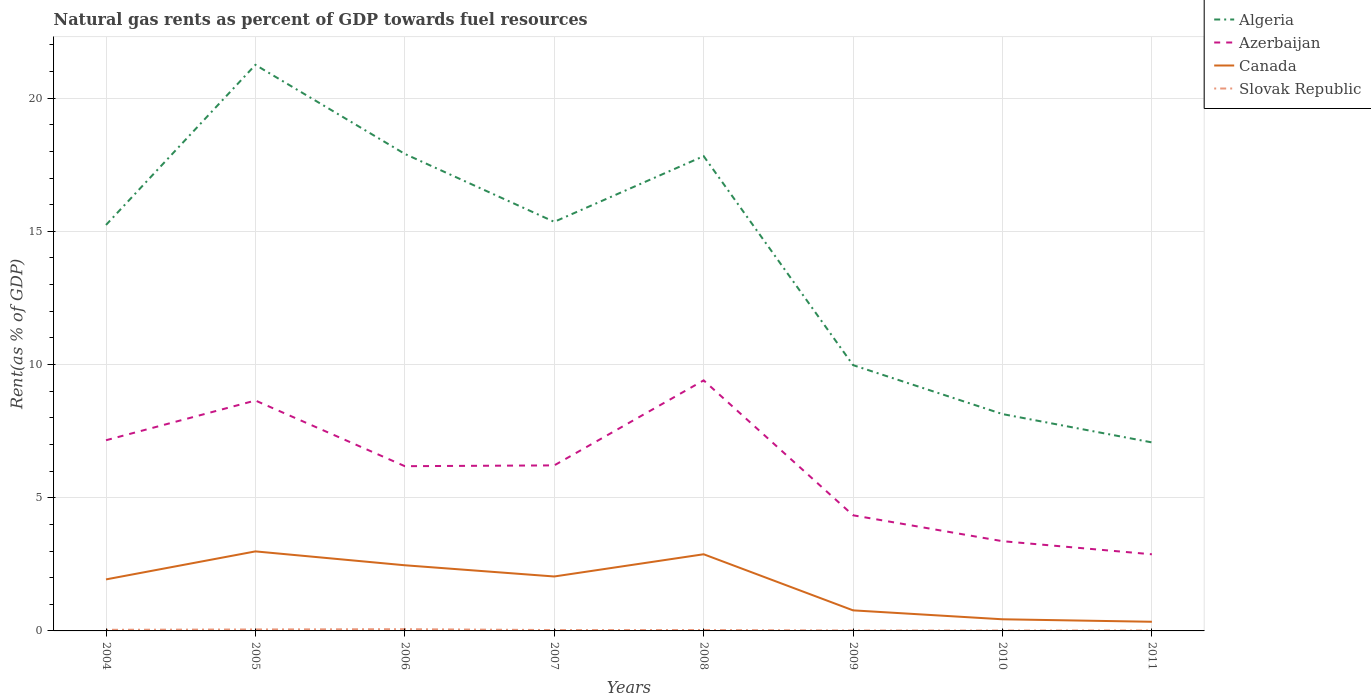Across all years, what is the maximum matural gas rent in Algeria?
Your answer should be very brief. 7.08. In which year was the matural gas rent in Slovak Republic maximum?
Make the answer very short. 2010. What is the total matural gas rent in Slovak Republic in the graph?
Ensure brevity in your answer.  0.03. What is the difference between the highest and the second highest matural gas rent in Algeria?
Keep it short and to the point. 14.17. What is the difference between the highest and the lowest matural gas rent in Algeria?
Offer a very short reply. 5. Is the matural gas rent in Azerbaijan strictly greater than the matural gas rent in Algeria over the years?
Offer a very short reply. Yes. How many lines are there?
Ensure brevity in your answer.  4. How many years are there in the graph?
Ensure brevity in your answer.  8. What is the difference between two consecutive major ticks on the Y-axis?
Your answer should be compact. 5. Does the graph contain grids?
Provide a short and direct response. Yes. How many legend labels are there?
Your answer should be very brief. 4. What is the title of the graph?
Give a very brief answer. Natural gas rents as percent of GDP towards fuel resources. What is the label or title of the Y-axis?
Offer a terse response. Rent(as % of GDP). What is the Rent(as % of GDP) in Algeria in 2004?
Make the answer very short. 15.24. What is the Rent(as % of GDP) in Azerbaijan in 2004?
Provide a short and direct response. 7.16. What is the Rent(as % of GDP) in Canada in 2004?
Your answer should be very brief. 1.93. What is the Rent(as % of GDP) in Slovak Republic in 2004?
Give a very brief answer. 0.04. What is the Rent(as % of GDP) in Algeria in 2005?
Give a very brief answer. 21.25. What is the Rent(as % of GDP) of Azerbaijan in 2005?
Your answer should be compact. 8.65. What is the Rent(as % of GDP) of Canada in 2005?
Your answer should be very brief. 2.99. What is the Rent(as % of GDP) of Slovak Republic in 2005?
Make the answer very short. 0.05. What is the Rent(as % of GDP) of Algeria in 2006?
Offer a very short reply. 17.91. What is the Rent(as % of GDP) in Azerbaijan in 2006?
Your answer should be compact. 6.18. What is the Rent(as % of GDP) in Canada in 2006?
Your response must be concise. 2.46. What is the Rent(as % of GDP) in Slovak Republic in 2006?
Your answer should be compact. 0.07. What is the Rent(as % of GDP) in Algeria in 2007?
Ensure brevity in your answer.  15.36. What is the Rent(as % of GDP) in Azerbaijan in 2007?
Offer a very short reply. 6.21. What is the Rent(as % of GDP) of Canada in 2007?
Give a very brief answer. 2.04. What is the Rent(as % of GDP) in Slovak Republic in 2007?
Your answer should be compact. 0.03. What is the Rent(as % of GDP) of Algeria in 2008?
Provide a short and direct response. 17.82. What is the Rent(as % of GDP) in Azerbaijan in 2008?
Your response must be concise. 9.41. What is the Rent(as % of GDP) of Canada in 2008?
Offer a very short reply. 2.88. What is the Rent(as % of GDP) of Slovak Republic in 2008?
Give a very brief answer. 0.03. What is the Rent(as % of GDP) in Algeria in 2009?
Offer a very short reply. 9.98. What is the Rent(as % of GDP) in Azerbaijan in 2009?
Make the answer very short. 4.34. What is the Rent(as % of GDP) in Canada in 2009?
Offer a very short reply. 0.77. What is the Rent(as % of GDP) in Slovak Republic in 2009?
Make the answer very short. 0.02. What is the Rent(as % of GDP) in Algeria in 2010?
Provide a succinct answer. 8.14. What is the Rent(as % of GDP) in Azerbaijan in 2010?
Your answer should be compact. 3.37. What is the Rent(as % of GDP) in Canada in 2010?
Provide a short and direct response. 0.44. What is the Rent(as % of GDP) of Slovak Republic in 2010?
Offer a terse response. 0.01. What is the Rent(as % of GDP) of Algeria in 2011?
Ensure brevity in your answer.  7.08. What is the Rent(as % of GDP) of Azerbaijan in 2011?
Provide a succinct answer. 2.88. What is the Rent(as % of GDP) of Canada in 2011?
Offer a very short reply. 0.34. What is the Rent(as % of GDP) in Slovak Republic in 2011?
Give a very brief answer. 0.02. Across all years, what is the maximum Rent(as % of GDP) of Algeria?
Offer a very short reply. 21.25. Across all years, what is the maximum Rent(as % of GDP) of Azerbaijan?
Offer a very short reply. 9.41. Across all years, what is the maximum Rent(as % of GDP) of Canada?
Your answer should be very brief. 2.99. Across all years, what is the maximum Rent(as % of GDP) in Slovak Republic?
Make the answer very short. 0.07. Across all years, what is the minimum Rent(as % of GDP) of Algeria?
Keep it short and to the point. 7.08. Across all years, what is the minimum Rent(as % of GDP) of Azerbaijan?
Provide a succinct answer. 2.88. Across all years, what is the minimum Rent(as % of GDP) of Canada?
Your response must be concise. 0.34. Across all years, what is the minimum Rent(as % of GDP) in Slovak Republic?
Offer a terse response. 0.01. What is the total Rent(as % of GDP) in Algeria in the graph?
Your response must be concise. 112.78. What is the total Rent(as % of GDP) in Azerbaijan in the graph?
Make the answer very short. 48.2. What is the total Rent(as % of GDP) of Canada in the graph?
Give a very brief answer. 13.86. What is the total Rent(as % of GDP) of Slovak Republic in the graph?
Make the answer very short. 0.28. What is the difference between the Rent(as % of GDP) of Algeria in 2004 and that in 2005?
Provide a succinct answer. -6.01. What is the difference between the Rent(as % of GDP) in Azerbaijan in 2004 and that in 2005?
Provide a short and direct response. -1.49. What is the difference between the Rent(as % of GDP) of Canada in 2004 and that in 2005?
Your response must be concise. -1.05. What is the difference between the Rent(as % of GDP) in Slovak Republic in 2004 and that in 2005?
Your response must be concise. -0.01. What is the difference between the Rent(as % of GDP) in Algeria in 2004 and that in 2006?
Give a very brief answer. -2.67. What is the difference between the Rent(as % of GDP) of Azerbaijan in 2004 and that in 2006?
Offer a very short reply. 0.97. What is the difference between the Rent(as % of GDP) in Canada in 2004 and that in 2006?
Make the answer very short. -0.53. What is the difference between the Rent(as % of GDP) of Slovak Republic in 2004 and that in 2006?
Ensure brevity in your answer.  -0.02. What is the difference between the Rent(as % of GDP) in Algeria in 2004 and that in 2007?
Give a very brief answer. -0.12. What is the difference between the Rent(as % of GDP) in Azerbaijan in 2004 and that in 2007?
Make the answer very short. 0.94. What is the difference between the Rent(as % of GDP) of Canada in 2004 and that in 2007?
Make the answer very short. -0.11. What is the difference between the Rent(as % of GDP) of Slovak Republic in 2004 and that in 2007?
Provide a succinct answer. 0.01. What is the difference between the Rent(as % of GDP) in Algeria in 2004 and that in 2008?
Make the answer very short. -2.58. What is the difference between the Rent(as % of GDP) of Azerbaijan in 2004 and that in 2008?
Offer a terse response. -2.25. What is the difference between the Rent(as % of GDP) in Canada in 2004 and that in 2008?
Offer a very short reply. -0.94. What is the difference between the Rent(as % of GDP) in Slovak Republic in 2004 and that in 2008?
Your response must be concise. 0.01. What is the difference between the Rent(as % of GDP) in Algeria in 2004 and that in 2009?
Offer a terse response. 5.26. What is the difference between the Rent(as % of GDP) of Azerbaijan in 2004 and that in 2009?
Your response must be concise. 2.82. What is the difference between the Rent(as % of GDP) in Canada in 2004 and that in 2009?
Your answer should be very brief. 1.16. What is the difference between the Rent(as % of GDP) of Slovak Republic in 2004 and that in 2009?
Your response must be concise. 0.03. What is the difference between the Rent(as % of GDP) of Algeria in 2004 and that in 2010?
Your answer should be compact. 7.1. What is the difference between the Rent(as % of GDP) in Azerbaijan in 2004 and that in 2010?
Make the answer very short. 3.79. What is the difference between the Rent(as % of GDP) in Canada in 2004 and that in 2010?
Your response must be concise. 1.5. What is the difference between the Rent(as % of GDP) of Slovak Republic in 2004 and that in 2010?
Your response must be concise. 0.03. What is the difference between the Rent(as % of GDP) in Algeria in 2004 and that in 2011?
Make the answer very short. 8.16. What is the difference between the Rent(as % of GDP) of Azerbaijan in 2004 and that in 2011?
Provide a succinct answer. 4.28. What is the difference between the Rent(as % of GDP) in Canada in 2004 and that in 2011?
Give a very brief answer. 1.59. What is the difference between the Rent(as % of GDP) of Slovak Republic in 2004 and that in 2011?
Keep it short and to the point. 0.03. What is the difference between the Rent(as % of GDP) in Algeria in 2005 and that in 2006?
Provide a succinct answer. 3.34. What is the difference between the Rent(as % of GDP) of Azerbaijan in 2005 and that in 2006?
Provide a succinct answer. 2.47. What is the difference between the Rent(as % of GDP) in Canada in 2005 and that in 2006?
Provide a short and direct response. 0.52. What is the difference between the Rent(as % of GDP) in Slovak Republic in 2005 and that in 2006?
Your response must be concise. -0.01. What is the difference between the Rent(as % of GDP) in Algeria in 2005 and that in 2007?
Offer a terse response. 5.89. What is the difference between the Rent(as % of GDP) in Azerbaijan in 2005 and that in 2007?
Provide a short and direct response. 2.44. What is the difference between the Rent(as % of GDP) of Canada in 2005 and that in 2007?
Keep it short and to the point. 0.94. What is the difference between the Rent(as % of GDP) in Slovak Republic in 2005 and that in 2007?
Your answer should be compact. 0.02. What is the difference between the Rent(as % of GDP) of Algeria in 2005 and that in 2008?
Your response must be concise. 3.43. What is the difference between the Rent(as % of GDP) of Azerbaijan in 2005 and that in 2008?
Make the answer very short. -0.76. What is the difference between the Rent(as % of GDP) of Canada in 2005 and that in 2008?
Offer a very short reply. 0.11. What is the difference between the Rent(as % of GDP) in Slovak Republic in 2005 and that in 2008?
Your response must be concise. 0.02. What is the difference between the Rent(as % of GDP) in Algeria in 2005 and that in 2009?
Offer a very short reply. 11.27. What is the difference between the Rent(as % of GDP) of Azerbaijan in 2005 and that in 2009?
Your answer should be very brief. 4.31. What is the difference between the Rent(as % of GDP) of Canada in 2005 and that in 2009?
Provide a succinct answer. 2.21. What is the difference between the Rent(as % of GDP) in Slovak Republic in 2005 and that in 2009?
Make the answer very short. 0.04. What is the difference between the Rent(as % of GDP) in Algeria in 2005 and that in 2010?
Give a very brief answer. 13.11. What is the difference between the Rent(as % of GDP) in Azerbaijan in 2005 and that in 2010?
Your answer should be very brief. 5.28. What is the difference between the Rent(as % of GDP) of Canada in 2005 and that in 2010?
Ensure brevity in your answer.  2.55. What is the difference between the Rent(as % of GDP) in Slovak Republic in 2005 and that in 2010?
Ensure brevity in your answer.  0.04. What is the difference between the Rent(as % of GDP) in Algeria in 2005 and that in 2011?
Make the answer very short. 14.17. What is the difference between the Rent(as % of GDP) in Azerbaijan in 2005 and that in 2011?
Offer a very short reply. 5.77. What is the difference between the Rent(as % of GDP) in Canada in 2005 and that in 2011?
Provide a succinct answer. 2.64. What is the difference between the Rent(as % of GDP) of Slovak Republic in 2005 and that in 2011?
Keep it short and to the point. 0.04. What is the difference between the Rent(as % of GDP) in Algeria in 2006 and that in 2007?
Your response must be concise. 2.55. What is the difference between the Rent(as % of GDP) of Azerbaijan in 2006 and that in 2007?
Make the answer very short. -0.03. What is the difference between the Rent(as % of GDP) in Canada in 2006 and that in 2007?
Provide a short and direct response. 0.42. What is the difference between the Rent(as % of GDP) of Slovak Republic in 2006 and that in 2007?
Provide a succinct answer. 0.03. What is the difference between the Rent(as % of GDP) of Algeria in 2006 and that in 2008?
Offer a very short reply. 0.08. What is the difference between the Rent(as % of GDP) in Azerbaijan in 2006 and that in 2008?
Your response must be concise. -3.22. What is the difference between the Rent(as % of GDP) in Canada in 2006 and that in 2008?
Ensure brevity in your answer.  -0.41. What is the difference between the Rent(as % of GDP) of Slovak Republic in 2006 and that in 2008?
Offer a very short reply. 0.03. What is the difference between the Rent(as % of GDP) in Algeria in 2006 and that in 2009?
Give a very brief answer. 7.93. What is the difference between the Rent(as % of GDP) in Azerbaijan in 2006 and that in 2009?
Ensure brevity in your answer.  1.84. What is the difference between the Rent(as % of GDP) in Canada in 2006 and that in 2009?
Make the answer very short. 1.69. What is the difference between the Rent(as % of GDP) of Slovak Republic in 2006 and that in 2009?
Your response must be concise. 0.05. What is the difference between the Rent(as % of GDP) of Algeria in 2006 and that in 2010?
Provide a short and direct response. 9.77. What is the difference between the Rent(as % of GDP) in Azerbaijan in 2006 and that in 2010?
Keep it short and to the point. 2.82. What is the difference between the Rent(as % of GDP) of Canada in 2006 and that in 2010?
Offer a terse response. 2.03. What is the difference between the Rent(as % of GDP) in Slovak Republic in 2006 and that in 2010?
Your answer should be very brief. 0.05. What is the difference between the Rent(as % of GDP) of Algeria in 2006 and that in 2011?
Your answer should be very brief. 10.83. What is the difference between the Rent(as % of GDP) in Azerbaijan in 2006 and that in 2011?
Provide a short and direct response. 3.31. What is the difference between the Rent(as % of GDP) in Canada in 2006 and that in 2011?
Your response must be concise. 2.12. What is the difference between the Rent(as % of GDP) of Slovak Republic in 2006 and that in 2011?
Make the answer very short. 0.05. What is the difference between the Rent(as % of GDP) of Algeria in 2007 and that in 2008?
Your answer should be very brief. -2.47. What is the difference between the Rent(as % of GDP) in Azerbaijan in 2007 and that in 2008?
Offer a very short reply. -3.19. What is the difference between the Rent(as % of GDP) of Canada in 2007 and that in 2008?
Offer a very short reply. -0.83. What is the difference between the Rent(as % of GDP) of Slovak Republic in 2007 and that in 2008?
Your answer should be very brief. -0. What is the difference between the Rent(as % of GDP) of Algeria in 2007 and that in 2009?
Keep it short and to the point. 5.38. What is the difference between the Rent(as % of GDP) of Azerbaijan in 2007 and that in 2009?
Your answer should be compact. 1.87. What is the difference between the Rent(as % of GDP) of Canada in 2007 and that in 2009?
Give a very brief answer. 1.27. What is the difference between the Rent(as % of GDP) in Slovak Republic in 2007 and that in 2009?
Provide a short and direct response. 0.02. What is the difference between the Rent(as % of GDP) in Algeria in 2007 and that in 2010?
Ensure brevity in your answer.  7.22. What is the difference between the Rent(as % of GDP) in Azerbaijan in 2007 and that in 2010?
Your answer should be compact. 2.85. What is the difference between the Rent(as % of GDP) of Canada in 2007 and that in 2010?
Your answer should be compact. 1.61. What is the difference between the Rent(as % of GDP) of Slovak Republic in 2007 and that in 2010?
Offer a terse response. 0.02. What is the difference between the Rent(as % of GDP) of Algeria in 2007 and that in 2011?
Provide a succinct answer. 8.28. What is the difference between the Rent(as % of GDP) of Azerbaijan in 2007 and that in 2011?
Your answer should be very brief. 3.34. What is the difference between the Rent(as % of GDP) in Canada in 2007 and that in 2011?
Offer a very short reply. 1.7. What is the difference between the Rent(as % of GDP) in Slovak Republic in 2007 and that in 2011?
Your response must be concise. 0.02. What is the difference between the Rent(as % of GDP) of Algeria in 2008 and that in 2009?
Your response must be concise. 7.85. What is the difference between the Rent(as % of GDP) in Azerbaijan in 2008 and that in 2009?
Provide a short and direct response. 5.07. What is the difference between the Rent(as % of GDP) of Canada in 2008 and that in 2009?
Offer a very short reply. 2.11. What is the difference between the Rent(as % of GDP) of Slovak Republic in 2008 and that in 2009?
Keep it short and to the point. 0.02. What is the difference between the Rent(as % of GDP) in Algeria in 2008 and that in 2010?
Your answer should be compact. 9.68. What is the difference between the Rent(as % of GDP) of Azerbaijan in 2008 and that in 2010?
Provide a short and direct response. 6.04. What is the difference between the Rent(as % of GDP) in Canada in 2008 and that in 2010?
Make the answer very short. 2.44. What is the difference between the Rent(as % of GDP) in Slovak Republic in 2008 and that in 2010?
Offer a terse response. 0.02. What is the difference between the Rent(as % of GDP) in Algeria in 2008 and that in 2011?
Ensure brevity in your answer.  10.75. What is the difference between the Rent(as % of GDP) of Azerbaijan in 2008 and that in 2011?
Provide a short and direct response. 6.53. What is the difference between the Rent(as % of GDP) in Canada in 2008 and that in 2011?
Offer a very short reply. 2.53. What is the difference between the Rent(as % of GDP) in Slovak Republic in 2008 and that in 2011?
Provide a succinct answer. 0.02. What is the difference between the Rent(as % of GDP) in Algeria in 2009 and that in 2010?
Ensure brevity in your answer.  1.84. What is the difference between the Rent(as % of GDP) in Azerbaijan in 2009 and that in 2010?
Make the answer very short. 0.97. What is the difference between the Rent(as % of GDP) of Canada in 2009 and that in 2010?
Provide a short and direct response. 0.34. What is the difference between the Rent(as % of GDP) in Slovak Republic in 2009 and that in 2010?
Your answer should be very brief. 0. What is the difference between the Rent(as % of GDP) in Algeria in 2009 and that in 2011?
Ensure brevity in your answer.  2.9. What is the difference between the Rent(as % of GDP) in Azerbaijan in 2009 and that in 2011?
Your answer should be very brief. 1.46. What is the difference between the Rent(as % of GDP) in Canada in 2009 and that in 2011?
Keep it short and to the point. 0.43. What is the difference between the Rent(as % of GDP) of Slovak Republic in 2009 and that in 2011?
Your response must be concise. -0. What is the difference between the Rent(as % of GDP) of Algeria in 2010 and that in 2011?
Give a very brief answer. 1.06. What is the difference between the Rent(as % of GDP) of Azerbaijan in 2010 and that in 2011?
Provide a succinct answer. 0.49. What is the difference between the Rent(as % of GDP) of Canada in 2010 and that in 2011?
Make the answer very short. 0.09. What is the difference between the Rent(as % of GDP) of Slovak Republic in 2010 and that in 2011?
Ensure brevity in your answer.  -0. What is the difference between the Rent(as % of GDP) of Algeria in 2004 and the Rent(as % of GDP) of Azerbaijan in 2005?
Offer a terse response. 6.59. What is the difference between the Rent(as % of GDP) in Algeria in 2004 and the Rent(as % of GDP) in Canada in 2005?
Your answer should be compact. 12.25. What is the difference between the Rent(as % of GDP) in Algeria in 2004 and the Rent(as % of GDP) in Slovak Republic in 2005?
Keep it short and to the point. 15.19. What is the difference between the Rent(as % of GDP) of Azerbaijan in 2004 and the Rent(as % of GDP) of Canada in 2005?
Your answer should be compact. 4.17. What is the difference between the Rent(as % of GDP) of Azerbaijan in 2004 and the Rent(as % of GDP) of Slovak Republic in 2005?
Provide a succinct answer. 7.1. What is the difference between the Rent(as % of GDP) in Canada in 2004 and the Rent(as % of GDP) in Slovak Republic in 2005?
Provide a short and direct response. 1.88. What is the difference between the Rent(as % of GDP) of Algeria in 2004 and the Rent(as % of GDP) of Azerbaijan in 2006?
Provide a succinct answer. 9.06. What is the difference between the Rent(as % of GDP) of Algeria in 2004 and the Rent(as % of GDP) of Canada in 2006?
Your answer should be very brief. 12.78. What is the difference between the Rent(as % of GDP) in Algeria in 2004 and the Rent(as % of GDP) in Slovak Republic in 2006?
Provide a short and direct response. 15.18. What is the difference between the Rent(as % of GDP) in Azerbaijan in 2004 and the Rent(as % of GDP) in Canada in 2006?
Give a very brief answer. 4.69. What is the difference between the Rent(as % of GDP) of Azerbaijan in 2004 and the Rent(as % of GDP) of Slovak Republic in 2006?
Your response must be concise. 7.09. What is the difference between the Rent(as % of GDP) of Canada in 2004 and the Rent(as % of GDP) of Slovak Republic in 2006?
Ensure brevity in your answer.  1.87. What is the difference between the Rent(as % of GDP) of Algeria in 2004 and the Rent(as % of GDP) of Azerbaijan in 2007?
Your answer should be compact. 9.03. What is the difference between the Rent(as % of GDP) of Algeria in 2004 and the Rent(as % of GDP) of Canada in 2007?
Offer a very short reply. 13.2. What is the difference between the Rent(as % of GDP) of Algeria in 2004 and the Rent(as % of GDP) of Slovak Republic in 2007?
Ensure brevity in your answer.  15.21. What is the difference between the Rent(as % of GDP) in Azerbaijan in 2004 and the Rent(as % of GDP) in Canada in 2007?
Make the answer very short. 5.12. What is the difference between the Rent(as % of GDP) in Azerbaijan in 2004 and the Rent(as % of GDP) in Slovak Republic in 2007?
Give a very brief answer. 7.13. What is the difference between the Rent(as % of GDP) of Canada in 2004 and the Rent(as % of GDP) of Slovak Republic in 2007?
Offer a terse response. 1.9. What is the difference between the Rent(as % of GDP) of Algeria in 2004 and the Rent(as % of GDP) of Azerbaijan in 2008?
Make the answer very short. 5.83. What is the difference between the Rent(as % of GDP) in Algeria in 2004 and the Rent(as % of GDP) in Canada in 2008?
Keep it short and to the point. 12.36. What is the difference between the Rent(as % of GDP) of Algeria in 2004 and the Rent(as % of GDP) of Slovak Republic in 2008?
Keep it short and to the point. 15.21. What is the difference between the Rent(as % of GDP) of Azerbaijan in 2004 and the Rent(as % of GDP) of Canada in 2008?
Offer a terse response. 4.28. What is the difference between the Rent(as % of GDP) of Azerbaijan in 2004 and the Rent(as % of GDP) of Slovak Republic in 2008?
Offer a very short reply. 7.12. What is the difference between the Rent(as % of GDP) in Canada in 2004 and the Rent(as % of GDP) in Slovak Republic in 2008?
Ensure brevity in your answer.  1.9. What is the difference between the Rent(as % of GDP) of Algeria in 2004 and the Rent(as % of GDP) of Azerbaijan in 2009?
Your response must be concise. 10.9. What is the difference between the Rent(as % of GDP) in Algeria in 2004 and the Rent(as % of GDP) in Canada in 2009?
Your answer should be very brief. 14.47. What is the difference between the Rent(as % of GDP) of Algeria in 2004 and the Rent(as % of GDP) of Slovak Republic in 2009?
Your response must be concise. 15.22. What is the difference between the Rent(as % of GDP) of Azerbaijan in 2004 and the Rent(as % of GDP) of Canada in 2009?
Give a very brief answer. 6.39. What is the difference between the Rent(as % of GDP) of Azerbaijan in 2004 and the Rent(as % of GDP) of Slovak Republic in 2009?
Ensure brevity in your answer.  7.14. What is the difference between the Rent(as % of GDP) in Canada in 2004 and the Rent(as % of GDP) in Slovak Republic in 2009?
Your answer should be very brief. 1.92. What is the difference between the Rent(as % of GDP) of Algeria in 2004 and the Rent(as % of GDP) of Azerbaijan in 2010?
Your answer should be compact. 11.87. What is the difference between the Rent(as % of GDP) of Algeria in 2004 and the Rent(as % of GDP) of Canada in 2010?
Offer a terse response. 14.8. What is the difference between the Rent(as % of GDP) of Algeria in 2004 and the Rent(as % of GDP) of Slovak Republic in 2010?
Make the answer very short. 15.23. What is the difference between the Rent(as % of GDP) of Azerbaijan in 2004 and the Rent(as % of GDP) of Canada in 2010?
Offer a very short reply. 6.72. What is the difference between the Rent(as % of GDP) of Azerbaijan in 2004 and the Rent(as % of GDP) of Slovak Republic in 2010?
Your answer should be compact. 7.14. What is the difference between the Rent(as % of GDP) of Canada in 2004 and the Rent(as % of GDP) of Slovak Republic in 2010?
Your response must be concise. 1.92. What is the difference between the Rent(as % of GDP) in Algeria in 2004 and the Rent(as % of GDP) in Azerbaijan in 2011?
Your answer should be very brief. 12.36. What is the difference between the Rent(as % of GDP) in Algeria in 2004 and the Rent(as % of GDP) in Canada in 2011?
Ensure brevity in your answer.  14.9. What is the difference between the Rent(as % of GDP) of Algeria in 2004 and the Rent(as % of GDP) of Slovak Republic in 2011?
Ensure brevity in your answer.  15.22. What is the difference between the Rent(as % of GDP) of Azerbaijan in 2004 and the Rent(as % of GDP) of Canada in 2011?
Your answer should be very brief. 6.81. What is the difference between the Rent(as % of GDP) of Azerbaijan in 2004 and the Rent(as % of GDP) of Slovak Republic in 2011?
Provide a succinct answer. 7.14. What is the difference between the Rent(as % of GDP) of Canada in 2004 and the Rent(as % of GDP) of Slovak Republic in 2011?
Offer a terse response. 1.92. What is the difference between the Rent(as % of GDP) in Algeria in 2005 and the Rent(as % of GDP) in Azerbaijan in 2006?
Ensure brevity in your answer.  15.07. What is the difference between the Rent(as % of GDP) of Algeria in 2005 and the Rent(as % of GDP) of Canada in 2006?
Offer a very short reply. 18.79. What is the difference between the Rent(as % of GDP) of Algeria in 2005 and the Rent(as % of GDP) of Slovak Republic in 2006?
Your answer should be very brief. 21.19. What is the difference between the Rent(as % of GDP) of Azerbaijan in 2005 and the Rent(as % of GDP) of Canada in 2006?
Offer a terse response. 6.18. What is the difference between the Rent(as % of GDP) of Azerbaijan in 2005 and the Rent(as % of GDP) of Slovak Republic in 2006?
Your answer should be very brief. 8.58. What is the difference between the Rent(as % of GDP) in Canada in 2005 and the Rent(as % of GDP) in Slovak Republic in 2006?
Make the answer very short. 2.92. What is the difference between the Rent(as % of GDP) in Algeria in 2005 and the Rent(as % of GDP) in Azerbaijan in 2007?
Offer a terse response. 15.04. What is the difference between the Rent(as % of GDP) of Algeria in 2005 and the Rent(as % of GDP) of Canada in 2007?
Your response must be concise. 19.21. What is the difference between the Rent(as % of GDP) of Algeria in 2005 and the Rent(as % of GDP) of Slovak Republic in 2007?
Offer a terse response. 21.22. What is the difference between the Rent(as % of GDP) in Azerbaijan in 2005 and the Rent(as % of GDP) in Canada in 2007?
Provide a short and direct response. 6.61. What is the difference between the Rent(as % of GDP) of Azerbaijan in 2005 and the Rent(as % of GDP) of Slovak Republic in 2007?
Offer a very short reply. 8.62. What is the difference between the Rent(as % of GDP) in Canada in 2005 and the Rent(as % of GDP) in Slovak Republic in 2007?
Provide a succinct answer. 2.95. What is the difference between the Rent(as % of GDP) of Algeria in 2005 and the Rent(as % of GDP) of Azerbaijan in 2008?
Your answer should be very brief. 11.84. What is the difference between the Rent(as % of GDP) of Algeria in 2005 and the Rent(as % of GDP) of Canada in 2008?
Provide a short and direct response. 18.37. What is the difference between the Rent(as % of GDP) of Algeria in 2005 and the Rent(as % of GDP) of Slovak Republic in 2008?
Give a very brief answer. 21.22. What is the difference between the Rent(as % of GDP) of Azerbaijan in 2005 and the Rent(as % of GDP) of Canada in 2008?
Offer a very short reply. 5.77. What is the difference between the Rent(as % of GDP) of Azerbaijan in 2005 and the Rent(as % of GDP) of Slovak Republic in 2008?
Provide a succinct answer. 8.62. What is the difference between the Rent(as % of GDP) of Canada in 2005 and the Rent(as % of GDP) of Slovak Republic in 2008?
Keep it short and to the point. 2.95. What is the difference between the Rent(as % of GDP) in Algeria in 2005 and the Rent(as % of GDP) in Azerbaijan in 2009?
Give a very brief answer. 16.91. What is the difference between the Rent(as % of GDP) in Algeria in 2005 and the Rent(as % of GDP) in Canada in 2009?
Ensure brevity in your answer.  20.48. What is the difference between the Rent(as % of GDP) in Algeria in 2005 and the Rent(as % of GDP) in Slovak Republic in 2009?
Your response must be concise. 21.23. What is the difference between the Rent(as % of GDP) of Azerbaijan in 2005 and the Rent(as % of GDP) of Canada in 2009?
Your answer should be compact. 7.88. What is the difference between the Rent(as % of GDP) in Azerbaijan in 2005 and the Rent(as % of GDP) in Slovak Republic in 2009?
Your response must be concise. 8.63. What is the difference between the Rent(as % of GDP) of Canada in 2005 and the Rent(as % of GDP) of Slovak Republic in 2009?
Ensure brevity in your answer.  2.97. What is the difference between the Rent(as % of GDP) in Algeria in 2005 and the Rent(as % of GDP) in Azerbaijan in 2010?
Provide a short and direct response. 17.88. What is the difference between the Rent(as % of GDP) of Algeria in 2005 and the Rent(as % of GDP) of Canada in 2010?
Give a very brief answer. 20.81. What is the difference between the Rent(as % of GDP) in Algeria in 2005 and the Rent(as % of GDP) in Slovak Republic in 2010?
Offer a very short reply. 21.24. What is the difference between the Rent(as % of GDP) of Azerbaijan in 2005 and the Rent(as % of GDP) of Canada in 2010?
Offer a terse response. 8.21. What is the difference between the Rent(as % of GDP) in Azerbaijan in 2005 and the Rent(as % of GDP) in Slovak Republic in 2010?
Offer a very short reply. 8.64. What is the difference between the Rent(as % of GDP) of Canada in 2005 and the Rent(as % of GDP) of Slovak Republic in 2010?
Your answer should be very brief. 2.97. What is the difference between the Rent(as % of GDP) of Algeria in 2005 and the Rent(as % of GDP) of Azerbaijan in 2011?
Your response must be concise. 18.37. What is the difference between the Rent(as % of GDP) of Algeria in 2005 and the Rent(as % of GDP) of Canada in 2011?
Provide a succinct answer. 20.91. What is the difference between the Rent(as % of GDP) in Algeria in 2005 and the Rent(as % of GDP) in Slovak Republic in 2011?
Keep it short and to the point. 21.23. What is the difference between the Rent(as % of GDP) in Azerbaijan in 2005 and the Rent(as % of GDP) in Canada in 2011?
Ensure brevity in your answer.  8.31. What is the difference between the Rent(as % of GDP) of Azerbaijan in 2005 and the Rent(as % of GDP) of Slovak Republic in 2011?
Give a very brief answer. 8.63. What is the difference between the Rent(as % of GDP) of Canada in 2005 and the Rent(as % of GDP) of Slovak Republic in 2011?
Make the answer very short. 2.97. What is the difference between the Rent(as % of GDP) in Algeria in 2006 and the Rent(as % of GDP) in Azerbaijan in 2007?
Your answer should be very brief. 11.69. What is the difference between the Rent(as % of GDP) in Algeria in 2006 and the Rent(as % of GDP) in Canada in 2007?
Keep it short and to the point. 15.86. What is the difference between the Rent(as % of GDP) in Algeria in 2006 and the Rent(as % of GDP) in Slovak Republic in 2007?
Your answer should be very brief. 17.87. What is the difference between the Rent(as % of GDP) in Azerbaijan in 2006 and the Rent(as % of GDP) in Canada in 2007?
Provide a succinct answer. 4.14. What is the difference between the Rent(as % of GDP) in Azerbaijan in 2006 and the Rent(as % of GDP) in Slovak Republic in 2007?
Provide a short and direct response. 6.15. What is the difference between the Rent(as % of GDP) of Canada in 2006 and the Rent(as % of GDP) of Slovak Republic in 2007?
Provide a succinct answer. 2.43. What is the difference between the Rent(as % of GDP) in Algeria in 2006 and the Rent(as % of GDP) in Azerbaijan in 2008?
Your answer should be very brief. 8.5. What is the difference between the Rent(as % of GDP) in Algeria in 2006 and the Rent(as % of GDP) in Canada in 2008?
Offer a very short reply. 15.03. What is the difference between the Rent(as % of GDP) of Algeria in 2006 and the Rent(as % of GDP) of Slovak Republic in 2008?
Give a very brief answer. 17.87. What is the difference between the Rent(as % of GDP) in Azerbaijan in 2006 and the Rent(as % of GDP) in Canada in 2008?
Offer a terse response. 3.31. What is the difference between the Rent(as % of GDP) in Azerbaijan in 2006 and the Rent(as % of GDP) in Slovak Republic in 2008?
Offer a very short reply. 6.15. What is the difference between the Rent(as % of GDP) of Canada in 2006 and the Rent(as % of GDP) of Slovak Republic in 2008?
Provide a succinct answer. 2.43. What is the difference between the Rent(as % of GDP) in Algeria in 2006 and the Rent(as % of GDP) in Azerbaijan in 2009?
Your answer should be very brief. 13.57. What is the difference between the Rent(as % of GDP) of Algeria in 2006 and the Rent(as % of GDP) of Canada in 2009?
Provide a short and direct response. 17.14. What is the difference between the Rent(as % of GDP) in Algeria in 2006 and the Rent(as % of GDP) in Slovak Republic in 2009?
Your answer should be very brief. 17.89. What is the difference between the Rent(as % of GDP) in Azerbaijan in 2006 and the Rent(as % of GDP) in Canada in 2009?
Make the answer very short. 5.41. What is the difference between the Rent(as % of GDP) in Azerbaijan in 2006 and the Rent(as % of GDP) in Slovak Republic in 2009?
Offer a terse response. 6.17. What is the difference between the Rent(as % of GDP) of Canada in 2006 and the Rent(as % of GDP) of Slovak Republic in 2009?
Your response must be concise. 2.45. What is the difference between the Rent(as % of GDP) in Algeria in 2006 and the Rent(as % of GDP) in Azerbaijan in 2010?
Provide a short and direct response. 14.54. What is the difference between the Rent(as % of GDP) in Algeria in 2006 and the Rent(as % of GDP) in Canada in 2010?
Your answer should be very brief. 17.47. What is the difference between the Rent(as % of GDP) of Algeria in 2006 and the Rent(as % of GDP) of Slovak Republic in 2010?
Offer a terse response. 17.89. What is the difference between the Rent(as % of GDP) of Azerbaijan in 2006 and the Rent(as % of GDP) of Canada in 2010?
Your answer should be very brief. 5.75. What is the difference between the Rent(as % of GDP) in Azerbaijan in 2006 and the Rent(as % of GDP) in Slovak Republic in 2010?
Keep it short and to the point. 6.17. What is the difference between the Rent(as % of GDP) of Canada in 2006 and the Rent(as % of GDP) of Slovak Republic in 2010?
Ensure brevity in your answer.  2.45. What is the difference between the Rent(as % of GDP) in Algeria in 2006 and the Rent(as % of GDP) in Azerbaijan in 2011?
Offer a very short reply. 15.03. What is the difference between the Rent(as % of GDP) of Algeria in 2006 and the Rent(as % of GDP) of Canada in 2011?
Your answer should be compact. 17.56. What is the difference between the Rent(as % of GDP) of Algeria in 2006 and the Rent(as % of GDP) of Slovak Republic in 2011?
Offer a terse response. 17.89. What is the difference between the Rent(as % of GDP) in Azerbaijan in 2006 and the Rent(as % of GDP) in Canada in 2011?
Offer a very short reply. 5.84. What is the difference between the Rent(as % of GDP) of Azerbaijan in 2006 and the Rent(as % of GDP) of Slovak Republic in 2011?
Give a very brief answer. 6.17. What is the difference between the Rent(as % of GDP) in Canada in 2006 and the Rent(as % of GDP) in Slovak Republic in 2011?
Your response must be concise. 2.45. What is the difference between the Rent(as % of GDP) in Algeria in 2007 and the Rent(as % of GDP) in Azerbaijan in 2008?
Offer a terse response. 5.95. What is the difference between the Rent(as % of GDP) of Algeria in 2007 and the Rent(as % of GDP) of Canada in 2008?
Keep it short and to the point. 12.48. What is the difference between the Rent(as % of GDP) of Algeria in 2007 and the Rent(as % of GDP) of Slovak Republic in 2008?
Offer a terse response. 15.32. What is the difference between the Rent(as % of GDP) in Azerbaijan in 2007 and the Rent(as % of GDP) in Canada in 2008?
Provide a short and direct response. 3.34. What is the difference between the Rent(as % of GDP) in Azerbaijan in 2007 and the Rent(as % of GDP) in Slovak Republic in 2008?
Keep it short and to the point. 6.18. What is the difference between the Rent(as % of GDP) of Canada in 2007 and the Rent(as % of GDP) of Slovak Republic in 2008?
Offer a very short reply. 2.01. What is the difference between the Rent(as % of GDP) of Algeria in 2007 and the Rent(as % of GDP) of Azerbaijan in 2009?
Provide a succinct answer. 11.02. What is the difference between the Rent(as % of GDP) of Algeria in 2007 and the Rent(as % of GDP) of Canada in 2009?
Give a very brief answer. 14.59. What is the difference between the Rent(as % of GDP) in Algeria in 2007 and the Rent(as % of GDP) in Slovak Republic in 2009?
Your response must be concise. 15.34. What is the difference between the Rent(as % of GDP) in Azerbaijan in 2007 and the Rent(as % of GDP) in Canada in 2009?
Provide a succinct answer. 5.44. What is the difference between the Rent(as % of GDP) in Azerbaijan in 2007 and the Rent(as % of GDP) in Slovak Republic in 2009?
Your response must be concise. 6.2. What is the difference between the Rent(as % of GDP) of Canada in 2007 and the Rent(as % of GDP) of Slovak Republic in 2009?
Your answer should be very brief. 2.03. What is the difference between the Rent(as % of GDP) of Algeria in 2007 and the Rent(as % of GDP) of Azerbaijan in 2010?
Your answer should be very brief. 11.99. What is the difference between the Rent(as % of GDP) in Algeria in 2007 and the Rent(as % of GDP) in Canada in 2010?
Your answer should be compact. 14.92. What is the difference between the Rent(as % of GDP) in Algeria in 2007 and the Rent(as % of GDP) in Slovak Republic in 2010?
Offer a terse response. 15.34. What is the difference between the Rent(as % of GDP) of Azerbaijan in 2007 and the Rent(as % of GDP) of Canada in 2010?
Ensure brevity in your answer.  5.78. What is the difference between the Rent(as % of GDP) in Azerbaijan in 2007 and the Rent(as % of GDP) in Slovak Republic in 2010?
Give a very brief answer. 6.2. What is the difference between the Rent(as % of GDP) in Canada in 2007 and the Rent(as % of GDP) in Slovak Republic in 2010?
Your answer should be very brief. 2.03. What is the difference between the Rent(as % of GDP) of Algeria in 2007 and the Rent(as % of GDP) of Azerbaijan in 2011?
Your response must be concise. 12.48. What is the difference between the Rent(as % of GDP) of Algeria in 2007 and the Rent(as % of GDP) of Canada in 2011?
Your answer should be compact. 15.01. What is the difference between the Rent(as % of GDP) of Algeria in 2007 and the Rent(as % of GDP) of Slovak Republic in 2011?
Keep it short and to the point. 15.34. What is the difference between the Rent(as % of GDP) in Azerbaijan in 2007 and the Rent(as % of GDP) in Canada in 2011?
Make the answer very short. 5.87. What is the difference between the Rent(as % of GDP) in Azerbaijan in 2007 and the Rent(as % of GDP) in Slovak Republic in 2011?
Offer a very short reply. 6.2. What is the difference between the Rent(as % of GDP) in Canada in 2007 and the Rent(as % of GDP) in Slovak Republic in 2011?
Ensure brevity in your answer.  2.03. What is the difference between the Rent(as % of GDP) in Algeria in 2008 and the Rent(as % of GDP) in Azerbaijan in 2009?
Your response must be concise. 13.48. What is the difference between the Rent(as % of GDP) of Algeria in 2008 and the Rent(as % of GDP) of Canada in 2009?
Provide a succinct answer. 17.05. What is the difference between the Rent(as % of GDP) in Algeria in 2008 and the Rent(as % of GDP) in Slovak Republic in 2009?
Offer a very short reply. 17.81. What is the difference between the Rent(as % of GDP) in Azerbaijan in 2008 and the Rent(as % of GDP) in Canada in 2009?
Offer a very short reply. 8.63. What is the difference between the Rent(as % of GDP) of Azerbaijan in 2008 and the Rent(as % of GDP) of Slovak Republic in 2009?
Offer a terse response. 9.39. What is the difference between the Rent(as % of GDP) of Canada in 2008 and the Rent(as % of GDP) of Slovak Republic in 2009?
Offer a very short reply. 2.86. What is the difference between the Rent(as % of GDP) in Algeria in 2008 and the Rent(as % of GDP) in Azerbaijan in 2010?
Give a very brief answer. 14.46. What is the difference between the Rent(as % of GDP) in Algeria in 2008 and the Rent(as % of GDP) in Canada in 2010?
Provide a short and direct response. 17.39. What is the difference between the Rent(as % of GDP) in Algeria in 2008 and the Rent(as % of GDP) in Slovak Republic in 2010?
Provide a short and direct response. 17.81. What is the difference between the Rent(as % of GDP) in Azerbaijan in 2008 and the Rent(as % of GDP) in Canada in 2010?
Offer a terse response. 8.97. What is the difference between the Rent(as % of GDP) of Azerbaijan in 2008 and the Rent(as % of GDP) of Slovak Republic in 2010?
Give a very brief answer. 9.39. What is the difference between the Rent(as % of GDP) in Canada in 2008 and the Rent(as % of GDP) in Slovak Republic in 2010?
Offer a terse response. 2.86. What is the difference between the Rent(as % of GDP) in Algeria in 2008 and the Rent(as % of GDP) in Azerbaijan in 2011?
Keep it short and to the point. 14.95. What is the difference between the Rent(as % of GDP) of Algeria in 2008 and the Rent(as % of GDP) of Canada in 2011?
Provide a short and direct response. 17.48. What is the difference between the Rent(as % of GDP) in Algeria in 2008 and the Rent(as % of GDP) in Slovak Republic in 2011?
Make the answer very short. 17.81. What is the difference between the Rent(as % of GDP) in Azerbaijan in 2008 and the Rent(as % of GDP) in Canada in 2011?
Your response must be concise. 9.06. What is the difference between the Rent(as % of GDP) of Azerbaijan in 2008 and the Rent(as % of GDP) of Slovak Republic in 2011?
Your response must be concise. 9.39. What is the difference between the Rent(as % of GDP) in Canada in 2008 and the Rent(as % of GDP) in Slovak Republic in 2011?
Your response must be concise. 2.86. What is the difference between the Rent(as % of GDP) of Algeria in 2009 and the Rent(as % of GDP) of Azerbaijan in 2010?
Give a very brief answer. 6.61. What is the difference between the Rent(as % of GDP) in Algeria in 2009 and the Rent(as % of GDP) in Canada in 2010?
Provide a succinct answer. 9.54. What is the difference between the Rent(as % of GDP) in Algeria in 2009 and the Rent(as % of GDP) in Slovak Republic in 2010?
Your answer should be compact. 9.96. What is the difference between the Rent(as % of GDP) in Azerbaijan in 2009 and the Rent(as % of GDP) in Canada in 2010?
Your response must be concise. 3.9. What is the difference between the Rent(as % of GDP) in Azerbaijan in 2009 and the Rent(as % of GDP) in Slovak Republic in 2010?
Keep it short and to the point. 4.33. What is the difference between the Rent(as % of GDP) of Canada in 2009 and the Rent(as % of GDP) of Slovak Republic in 2010?
Provide a short and direct response. 0.76. What is the difference between the Rent(as % of GDP) of Algeria in 2009 and the Rent(as % of GDP) of Azerbaijan in 2011?
Make the answer very short. 7.1. What is the difference between the Rent(as % of GDP) in Algeria in 2009 and the Rent(as % of GDP) in Canada in 2011?
Offer a very short reply. 9.63. What is the difference between the Rent(as % of GDP) in Algeria in 2009 and the Rent(as % of GDP) in Slovak Republic in 2011?
Your answer should be compact. 9.96. What is the difference between the Rent(as % of GDP) in Azerbaijan in 2009 and the Rent(as % of GDP) in Canada in 2011?
Offer a very short reply. 4. What is the difference between the Rent(as % of GDP) in Azerbaijan in 2009 and the Rent(as % of GDP) in Slovak Republic in 2011?
Your answer should be very brief. 4.32. What is the difference between the Rent(as % of GDP) in Canada in 2009 and the Rent(as % of GDP) in Slovak Republic in 2011?
Offer a very short reply. 0.76. What is the difference between the Rent(as % of GDP) of Algeria in 2010 and the Rent(as % of GDP) of Azerbaijan in 2011?
Your answer should be very brief. 5.26. What is the difference between the Rent(as % of GDP) in Algeria in 2010 and the Rent(as % of GDP) in Canada in 2011?
Your answer should be very brief. 7.8. What is the difference between the Rent(as % of GDP) in Algeria in 2010 and the Rent(as % of GDP) in Slovak Republic in 2011?
Give a very brief answer. 8.12. What is the difference between the Rent(as % of GDP) in Azerbaijan in 2010 and the Rent(as % of GDP) in Canada in 2011?
Give a very brief answer. 3.02. What is the difference between the Rent(as % of GDP) in Azerbaijan in 2010 and the Rent(as % of GDP) in Slovak Republic in 2011?
Make the answer very short. 3.35. What is the difference between the Rent(as % of GDP) in Canada in 2010 and the Rent(as % of GDP) in Slovak Republic in 2011?
Keep it short and to the point. 0.42. What is the average Rent(as % of GDP) in Algeria per year?
Offer a terse response. 14.1. What is the average Rent(as % of GDP) of Azerbaijan per year?
Offer a very short reply. 6.02. What is the average Rent(as % of GDP) in Canada per year?
Ensure brevity in your answer.  1.73. What is the average Rent(as % of GDP) of Slovak Republic per year?
Your response must be concise. 0.03. In the year 2004, what is the difference between the Rent(as % of GDP) of Algeria and Rent(as % of GDP) of Azerbaijan?
Make the answer very short. 8.08. In the year 2004, what is the difference between the Rent(as % of GDP) of Algeria and Rent(as % of GDP) of Canada?
Provide a succinct answer. 13.31. In the year 2004, what is the difference between the Rent(as % of GDP) of Algeria and Rent(as % of GDP) of Slovak Republic?
Make the answer very short. 15.2. In the year 2004, what is the difference between the Rent(as % of GDP) in Azerbaijan and Rent(as % of GDP) in Canada?
Your answer should be very brief. 5.22. In the year 2004, what is the difference between the Rent(as % of GDP) in Azerbaijan and Rent(as % of GDP) in Slovak Republic?
Provide a short and direct response. 7.12. In the year 2004, what is the difference between the Rent(as % of GDP) in Canada and Rent(as % of GDP) in Slovak Republic?
Provide a succinct answer. 1.89. In the year 2005, what is the difference between the Rent(as % of GDP) in Algeria and Rent(as % of GDP) in Azerbaijan?
Your answer should be compact. 12.6. In the year 2005, what is the difference between the Rent(as % of GDP) in Algeria and Rent(as % of GDP) in Canada?
Provide a succinct answer. 18.26. In the year 2005, what is the difference between the Rent(as % of GDP) in Algeria and Rent(as % of GDP) in Slovak Republic?
Make the answer very short. 21.2. In the year 2005, what is the difference between the Rent(as % of GDP) in Azerbaijan and Rent(as % of GDP) in Canada?
Ensure brevity in your answer.  5.66. In the year 2005, what is the difference between the Rent(as % of GDP) in Azerbaijan and Rent(as % of GDP) in Slovak Republic?
Provide a succinct answer. 8.59. In the year 2005, what is the difference between the Rent(as % of GDP) of Canada and Rent(as % of GDP) of Slovak Republic?
Your answer should be very brief. 2.93. In the year 2006, what is the difference between the Rent(as % of GDP) in Algeria and Rent(as % of GDP) in Azerbaijan?
Ensure brevity in your answer.  11.72. In the year 2006, what is the difference between the Rent(as % of GDP) in Algeria and Rent(as % of GDP) in Canada?
Offer a very short reply. 15.44. In the year 2006, what is the difference between the Rent(as % of GDP) of Algeria and Rent(as % of GDP) of Slovak Republic?
Offer a terse response. 17.84. In the year 2006, what is the difference between the Rent(as % of GDP) in Azerbaijan and Rent(as % of GDP) in Canada?
Your response must be concise. 3.72. In the year 2006, what is the difference between the Rent(as % of GDP) of Azerbaijan and Rent(as % of GDP) of Slovak Republic?
Give a very brief answer. 6.12. In the year 2006, what is the difference between the Rent(as % of GDP) of Canada and Rent(as % of GDP) of Slovak Republic?
Offer a terse response. 2.4. In the year 2007, what is the difference between the Rent(as % of GDP) of Algeria and Rent(as % of GDP) of Azerbaijan?
Make the answer very short. 9.14. In the year 2007, what is the difference between the Rent(as % of GDP) of Algeria and Rent(as % of GDP) of Canada?
Offer a terse response. 13.31. In the year 2007, what is the difference between the Rent(as % of GDP) of Algeria and Rent(as % of GDP) of Slovak Republic?
Offer a very short reply. 15.32. In the year 2007, what is the difference between the Rent(as % of GDP) of Azerbaijan and Rent(as % of GDP) of Canada?
Your answer should be very brief. 4.17. In the year 2007, what is the difference between the Rent(as % of GDP) of Azerbaijan and Rent(as % of GDP) of Slovak Republic?
Keep it short and to the point. 6.18. In the year 2007, what is the difference between the Rent(as % of GDP) in Canada and Rent(as % of GDP) in Slovak Republic?
Your answer should be very brief. 2.01. In the year 2008, what is the difference between the Rent(as % of GDP) in Algeria and Rent(as % of GDP) in Azerbaijan?
Provide a short and direct response. 8.42. In the year 2008, what is the difference between the Rent(as % of GDP) of Algeria and Rent(as % of GDP) of Canada?
Your answer should be very brief. 14.95. In the year 2008, what is the difference between the Rent(as % of GDP) of Algeria and Rent(as % of GDP) of Slovak Republic?
Provide a short and direct response. 17.79. In the year 2008, what is the difference between the Rent(as % of GDP) in Azerbaijan and Rent(as % of GDP) in Canada?
Give a very brief answer. 6.53. In the year 2008, what is the difference between the Rent(as % of GDP) of Azerbaijan and Rent(as % of GDP) of Slovak Republic?
Ensure brevity in your answer.  9.37. In the year 2008, what is the difference between the Rent(as % of GDP) of Canada and Rent(as % of GDP) of Slovak Republic?
Your answer should be compact. 2.84. In the year 2009, what is the difference between the Rent(as % of GDP) in Algeria and Rent(as % of GDP) in Azerbaijan?
Give a very brief answer. 5.64. In the year 2009, what is the difference between the Rent(as % of GDP) in Algeria and Rent(as % of GDP) in Canada?
Give a very brief answer. 9.21. In the year 2009, what is the difference between the Rent(as % of GDP) in Algeria and Rent(as % of GDP) in Slovak Republic?
Keep it short and to the point. 9.96. In the year 2009, what is the difference between the Rent(as % of GDP) in Azerbaijan and Rent(as % of GDP) in Canada?
Keep it short and to the point. 3.57. In the year 2009, what is the difference between the Rent(as % of GDP) of Azerbaijan and Rent(as % of GDP) of Slovak Republic?
Make the answer very short. 4.33. In the year 2009, what is the difference between the Rent(as % of GDP) of Canada and Rent(as % of GDP) of Slovak Republic?
Give a very brief answer. 0.76. In the year 2010, what is the difference between the Rent(as % of GDP) of Algeria and Rent(as % of GDP) of Azerbaijan?
Your answer should be very brief. 4.77. In the year 2010, what is the difference between the Rent(as % of GDP) in Algeria and Rent(as % of GDP) in Canada?
Ensure brevity in your answer.  7.7. In the year 2010, what is the difference between the Rent(as % of GDP) in Algeria and Rent(as % of GDP) in Slovak Republic?
Offer a terse response. 8.13. In the year 2010, what is the difference between the Rent(as % of GDP) in Azerbaijan and Rent(as % of GDP) in Canada?
Provide a short and direct response. 2.93. In the year 2010, what is the difference between the Rent(as % of GDP) in Azerbaijan and Rent(as % of GDP) in Slovak Republic?
Make the answer very short. 3.35. In the year 2010, what is the difference between the Rent(as % of GDP) in Canada and Rent(as % of GDP) in Slovak Republic?
Offer a terse response. 0.42. In the year 2011, what is the difference between the Rent(as % of GDP) in Algeria and Rent(as % of GDP) in Azerbaijan?
Keep it short and to the point. 4.2. In the year 2011, what is the difference between the Rent(as % of GDP) in Algeria and Rent(as % of GDP) in Canada?
Your answer should be very brief. 6.73. In the year 2011, what is the difference between the Rent(as % of GDP) of Algeria and Rent(as % of GDP) of Slovak Republic?
Keep it short and to the point. 7.06. In the year 2011, what is the difference between the Rent(as % of GDP) in Azerbaijan and Rent(as % of GDP) in Canada?
Ensure brevity in your answer.  2.53. In the year 2011, what is the difference between the Rent(as % of GDP) of Azerbaijan and Rent(as % of GDP) of Slovak Republic?
Ensure brevity in your answer.  2.86. In the year 2011, what is the difference between the Rent(as % of GDP) in Canada and Rent(as % of GDP) in Slovak Republic?
Give a very brief answer. 0.33. What is the ratio of the Rent(as % of GDP) in Algeria in 2004 to that in 2005?
Make the answer very short. 0.72. What is the ratio of the Rent(as % of GDP) of Azerbaijan in 2004 to that in 2005?
Your response must be concise. 0.83. What is the ratio of the Rent(as % of GDP) of Canada in 2004 to that in 2005?
Keep it short and to the point. 0.65. What is the ratio of the Rent(as % of GDP) of Slovak Republic in 2004 to that in 2005?
Make the answer very short. 0.76. What is the ratio of the Rent(as % of GDP) in Algeria in 2004 to that in 2006?
Offer a terse response. 0.85. What is the ratio of the Rent(as % of GDP) of Azerbaijan in 2004 to that in 2006?
Keep it short and to the point. 1.16. What is the ratio of the Rent(as % of GDP) in Canada in 2004 to that in 2006?
Provide a short and direct response. 0.78. What is the ratio of the Rent(as % of GDP) of Slovak Republic in 2004 to that in 2006?
Offer a terse response. 0.64. What is the ratio of the Rent(as % of GDP) in Algeria in 2004 to that in 2007?
Give a very brief answer. 0.99. What is the ratio of the Rent(as % of GDP) in Azerbaijan in 2004 to that in 2007?
Your answer should be compact. 1.15. What is the ratio of the Rent(as % of GDP) in Canada in 2004 to that in 2007?
Your answer should be very brief. 0.95. What is the ratio of the Rent(as % of GDP) of Algeria in 2004 to that in 2008?
Make the answer very short. 0.85. What is the ratio of the Rent(as % of GDP) in Azerbaijan in 2004 to that in 2008?
Provide a short and direct response. 0.76. What is the ratio of the Rent(as % of GDP) in Canada in 2004 to that in 2008?
Provide a succinct answer. 0.67. What is the ratio of the Rent(as % of GDP) of Slovak Republic in 2004 to that in 2008?
Make the answer very short. 1.25. What is the ratio of the Rent(as % of GDP) in Algeria in 2004 to that in 2009?
Give a very brief answer. 1.53. What is the ratio of the Rent(as % of GDP) of Azerbaijan in 2004 to that in 2009?
Ensure brevity in your answer.  1.65. What is the ratio of the Rent(as % of GDP) of Canada in 2004 to that in 2009?
Provide a short and direct response. 2.5. What is the ratio of the Rent(as % of GDP) in Slovak Republic in 2004 to that in 2009?
Make the answer very short. 2.64. What is the ratio of the Rent(as % of GDP) of Algeria in 2004 to that in 2010?
Offer a terse response. 1.87. What is the ratio of the Rent(as % of GDP) in Azerbaijan in 2004 to that in 2010?
Ensure brevity in your answer.  2.13. What is the ratio of the Rent(as % of GDP) in Canada in 2004 to that in 2010?
Offer a terse response. 4.43. What is the ratio of the Rent(as % of GDP) in Slovak Republic in 2004 to that in 2010?
Give a very brief answer. 2.9. What is the ratio of the Rent(as % of GDP) of Algeria in 2004 to that in 2011?
Keep it short and to the point. 2.15. What is the ratio of the Rent(as % of GDP) in Azerbaijan in 2004 to that in 2011?
Provide a short and direct response. 2.49. What is the ratio of the Rent(as % of GDP) of Canada in 2004 to that in 2011?
Your answer should be compact. 5.63. What is the ratio of the Rent(as % of GDP) in Slovak Republic in 2004 to that in 2011?
Make the answer very short. 2.52. What is the ratio of the Rent(as % of GDP) of Algeria in 2005 to that in 2006?
Keep it short and to the point. 1.19. What is the ratio of the Rent(as % of GDP) of Azerbaijan in 2005 to that in 2006?
Ensure brevity in your answer.  1.4. What is the ratio of the Rent(as % of GDP) of Canada in 2005 to that in 2006?
Keep it short and to the point. 1.21. What is the ratio of the Rent(as % of GDP) of Slovak Republic in 2005 to that in 2006?
Your answer should be very brief. 0.84. What is the ratio of the Rent(as % of GDP) of Algeria in 2005 to that in 2007?
Give a very brief answer. 1.38. What is the ratio of the Rent(as % of GDP) of Azerbaijan in 2005 to that in 2007?
Your response must be concise. 1.39. What is the ratio of the Rent(as % of GDP) of Canada in 2005 to that in 2007?
Your response must be concise. 1.46. What is the ratio of the Rent(as % of GDP) of Slovak Republic in 2005 to that in 2007?
Provide a short and direct response. 1.68. What is the ratio of the Rent(as % of GDP) in Algeria in 2005 to that in 2008?
Make the answer very short. 1.19. What is the ratio of the Rent(as % of GDP) in Azerbaijan in 2005 to that in 2008?
Offer a very short reply. 0.92. What is the ratio of the Rent(as % of GDP) in Canada in 2005 to that in 2008?
Provide a short and direct response. 1.04. What is the ratio of the Rent(as % of GDP) of Slovak Republic in 2005 to that in 2008?
Your response must be concise. 1.64. What is the ratio of the Rent(as % of GDP) of Algeria in 2005 to that in 2009?
Your answer should be very brief. 2.13. What is the ratio of the Rent(as % of GDP) in Azerbaijan in 2005 to that in 2009?
Offer a terse response. 1.99. What is the ratio of the Rent(as % of GDP) in Canada in 2005 to that in 2009?
Offer a terse response. 3.87. What is the ratio of the Rent(as % of GDP) of Slovak Republic in 2005 to that in 2009?
Your answer should be very brief. 3.46. What is the ratio of the Rent(as % of GDP) of Algeria in 2005 to that in 2010?
Offer a terse response. 2.61. What is the ratio of the Rent(as % of GDP) in Azerbaijan in 2005 to that in 2010?
Your answer should be compact. 2.57. What is the ratio of the Rent(as % of GDP) of Canada in 2005 to that in 2010?
Ensure brevity in your answer.  6.83. What is the ratio of the Rent(as % of GDP) in Slovak Republic in 2005 to that in 2010?
Offer a very short reply. 3.8. What is the ratio of the Rent(as % of GDP) of Algeria in 2005 to that in 2011?
Provide a succinct answer. 3. What is the ratio of the Rent(as % of GDP) of Azerbaijan in 2005 to that in 2011?
Provide a succinct answer. 3.01. What is the ratio of the Rent(as % of GDP) in Canada in 2005 to that in 2011?
Keep it short and to the point. 8.68. What is the ratio of the Rent(as % of GDP) in Slovak Republic in 2005 to that in 2011?
Your response must be concise. 3.3. What is the ratio of the Rent(as % of GDP) of Algeria in 2006 to that in 2007?
Your answer should be compact. 1.17. What is the ratio of the Rent(as % of GDP) of Canada in 2006 to that in 2007?
Keep it short and to the point. 1.21. What is the ratio of the Rent(as % of GDP) in Slovak Republic in 2006 to that in 2007?
Your answer should be very brief. 2. What is the ratio of the Rent(as % of GDP) of Algeria in 2006 to that in 2008?
Provide a succinct answer. 1. What is the ratio of the Rent(as % of GDP) of Azerbaijan in 2006 to that in 2008?
Make the answer very short. 0.66. What is the ratio of the Rent(as % of GDP) of Canada in 2006 to that in 2008?
Your answer should be compact. 0.86. What is the ratio of the Rent(as % of GDP) of Slovak Republic in 2006 to that in 2008?
Offer a terse response. 1.95. What is the ratio of the Rent(as % of GDP) in Algeria in 2006 to that in 2009?
Give a very brief answer. 1.79. What is the ratio of the Rent(as % of GDP) in Azerbaijan in 2006 to that in 2009?
Your answer should be very brief. 1.42. What is the ratio of the Rent(as % of GDP) of Canada in 2006 to that in 2009?
Keep it short and to the point. 3.19. What is the ratio of the Rent(as % of GDP) of Slovak Republic in 2006 to that in 2009?
Give a very brief answer. 4.11. What is the ratio of the Rent(as % of GDP) in Algeria in 2006 to that in 2010?
Your answer should be compact. 2.2. What is the ratio of the Rent(as % of GDP) in Azerbaijan in 2006 to that in 2010?
Offer a very short reply. 1.84. What is the ratio of the Rent(as % of GDP) in Canada in 2006 to that in 2010?
Your answer should be very brief. 5.64. What is the ratio of the Rent(as % of GDP) of Slovak Republic in 2006 to that in 2010?
Your answer should be compact. 4.52. What is the ratio of the Rent(as % of GDP) of Algeria in 2006 to that in 2011?
Keep it short and to the point. 2.53. What is the ratio of the Rent(as % of GDP) of Azerbaijan in 2006 to that in 2011?
Provide a succinct answer. 2.15. What is the ratio of the Rent(as % of GDP) of Canada in 2006 to that in 2011?
Offer a very short reply. 7.17. What is the ratio of the Rent(as % of GDP) of Slovak Republic in 2006 to that in 2011?
Provide a short and direct response. 3.92. What is the ratio of the Rent(as % of GDP) in Algeria in 2007 to that in 2008?
Keep it short and to the point. 0.86. What is the ratio of the Rent(as % of GDP) in Azerbaijan in 2007 to that in 2008?
Your response must be concise. 0.66. What is the ratio of the Rent(as % of GDP) in Canada in 2007 to that in 2008?
Offer a very short reply. 0.71. What is the ratio of the Rent(as % of GDP) in Algeria in 2007 to that in 2009?
Give a very brief answer. 1.54. What is the ratio of the Rent(as % of GDP) in Azerbaijan in 2007 to that in 2009?
Offer a very short reply. 1.43. What is the ratio of the Rent(as % of GDP) of Canada in 2007 to that in 2009?
Give a very brief answer. 2.65. What is the ratio of the Rent(as % of GDP) of Slovak Republic in 2007 to that in 2009?
Make the answer very short. 2.06. What is the ratio of the Rent(as % of GDP) in Algeria in 2007 to that in 2010?
Provide a succinct answer. 1.89. What is the ratio of the Rent(as % of GDP) in Azerbaijan in 2007 to that in 2010?
Provide a short and direct response. 1.84. What is the ratio of the Rent(as % of GDP) in Canada in 2007 to that in 2010?
Provide a short and direct response. 4.68. What is the ratio of the Rent(as % of GDP) in Slovak Republic in 2007 to that in 2010?
Offer a terse response. 2.26. What is the ratio of the Rent(as % of GDP) in Algeria in 2007 to that in 2011?
Offer a terse response. 2.17. What is the ratio of the Rent(as % of GDP) in Azerbaijan in 2007 to that in 2011?
Ensure brevity in your answer.  2.16. What is the ratio of the Rent(as % of GDP) in Canada in 2007 to that in 2011?
Your answer should be compact. 5.94. What is the ratio of the Rent(as % of GDP) of Slovak Republic in 2007 to that in 2011?
Offer a terse response. 1.96. What is the ratio of the Rent(as % of GDP) of Algeria in 2008 to that in 2009?
Your response must be concise. 1.79. What is the ratio of the Rent(as % of GDP) in Azerbaijan in 2008 to that in 2009?
Your response must be concise. 2.17. What is the ratio of the Rent(as % of GDP) in Canada in 2008 to that in 2009?
Give a very brief answer. 3.73. What is the ratio of the Rent(as % of GDP) in Slovak Republic in 2008 to that in 2009?
Give a very brief answer. 2.11. What is the ratio of the Rent(as % of GDP) in Algeria in 2008 to that in 2010?
Give a very brief answer. 2.19. What is the ratio of the Rent(as % of GDP) of Azerbaijan in 2008 to that in 2010?
Ensure brevity in your answer.  2.79. What is the ratio of the Rent(as % of GDP) of Canada in 2008 to that in 2010?
Make the answer very short. 6.59. What is the ratio of the Rent(as % of GDP) in Slovak Republic in 2008 to that in 2010?
Make the answer very short. 2.32. What is the ratio of the Rent(as % of GDP) in Algeria in 2008 to that in 2011?
Give a very brief answer. 2.52. What is the ratio of the Rent(as % of GDP) in Azerbaijan in 2008 to that in 2011?
Provide a short and direct response. 3.27. What is the ratio of the Rent(as % of GDP) of Canada in 2008 to that in 2011?
Offer a very short reply. 8.37. What is the ratio of the Rent(as % of GDP) of Slovak Republic in 2008 to that in 2011?
Provide a short and direct response. 2.01. What is the ratio of the Rent(as % of GDP) in Algeria in 2009 to that in 2010?
Your answer should be compact. 1.23. What is the ratio of the Rent(as % of GDP) in Azerbaijan in 2009 to that in 2010?
Keep it short and to the point. 1.29. What is the ratio of the Rent(as % of GDP) of Canada in 2009 to that in 2010?
Keep it short and to the point. 1.77. What is the ratio of the Rent(as % of GDP) of Slovak Republic in 2009 to that in 2010?
Your answer should be compact. 1.1. What is the ratio of the Rent(as % of GDP) of Algeria in 2009 to that in 2011?
Provide a short and direct response. 1.41. What is the ratio of the Rent(as % of GDP) in Azerbaijan in 2009 to that in 2011?
Ensure brevity in your answer.  1.51. What is the ratio of the Rent(as % of GDP) of Canada in 2009 to that in 2011?
Make the answer very short. 2.25. What is the ratio of the Rent(as % of GDP) in Slovak Republic in 2009 to that in 2011?
Offer a terse response. 0.95. What is the ratio of the Rent(as % of GDP) of Algeria in 2010 to that in 2011?
Make the answer very short. 1.15. What is the ratio of the Rent(as % of GDP) in Azerbaijan in 2010 to that in 2011?
Offer a terse response. 1.17. What is the ratio of the Rent(as % of GDP) of Canada in 2010 to that in 2011?
Keep it short and to the point. 1.27. What is the ratio of the Rent(as % of GDP) of Slovak Republic in 2010 to that in 2011?
Offer a very short reply. 0.87. What is the difference between the highest and the second highest Rent(as % of GDP) of Algeria?
Your answer should be compact. 3.34. What is the difference between the highest and the second highest Rent(as % of GDP) of Azerbaijan?
Offer a very short reply. 0.76. What is the difference between the highest and the second highest Rent(as % of GDP) of Canada?
Ensure brevity in your answer.  0.11. What is the difference between the highest and the second highest Rent(as % of GDP) of Slovak Republic?
Ensure brevity in your answer.  0.01. What is the difference between the highest and the lowest Rent(as % of GDP) in Algeria?
Your answer should be compact. 14.17. What is the difference between the highest and the lowest Rent(as % of GDP) in Azerbaijan?
Offer a terse response. 6.53. What is the difference between the highest and the lowest Rent(as % of GDP) in Canada?
Your answer should be very brief. 2.64. What is the difference between the highest and the lowest Rent(as % of GDP) of Slovak Republic?
Your answer should be compact. 0.05. 